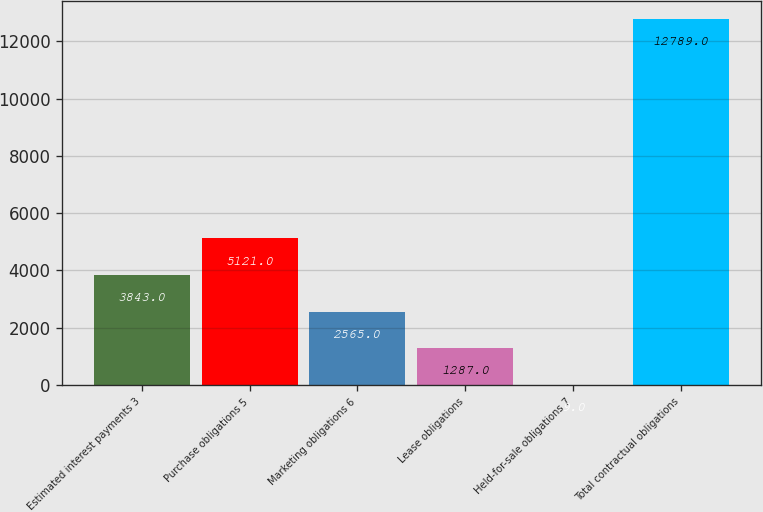Convert chart. <chart><loc_0><loc_0><loc_500><loc_500><bar_chart><fcel>Estimated interest payments 3<fcel>Purchase obligations 5<fcel>Marketing obligations 6<fcel>Lease obligations<fcel>Held-for-sale obligations 7<fcel>Total contractual obligations<nl><fcel>3843<fcel>5121<fcel>2565<fcel>1287<fcel>9<fcel>12789<nl></chart> 